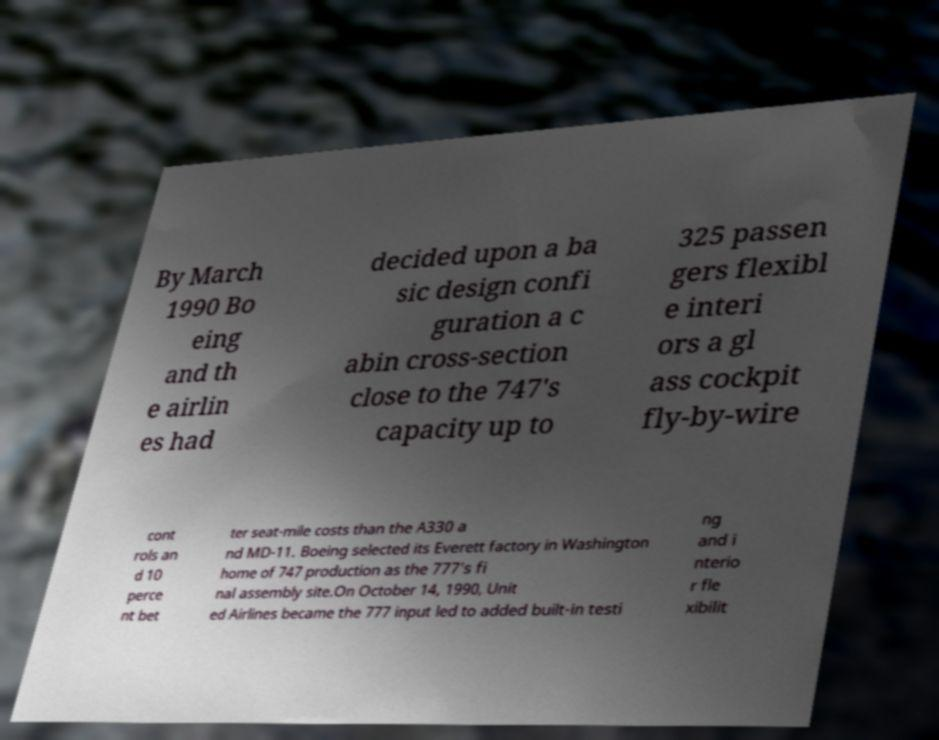I need the written content from this picture converted into text. Can you do that? By March 1990 Bo eing and th e airlin es had decided upon a ba sic design confi guration a c abin cross-section close to the 747's capacity up to 325 passen gers flexibl e interi ors a gl ass cockpit fly-by-wire cont rols an d 10 perce nt bet ter seat-mile costs than the A330 a nd MD-11. Boeing selected its Everett factory in Washington home of 747 production as the 777's fi nal assembly site.On October 14, 1990, Unit ed Airlines became the 777 input led to added built-in testi ng and i nterio r fle xibilit 